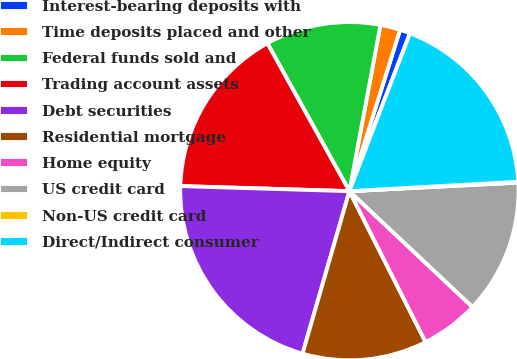Convert chart to OTSL. <chart><loc_0><loc_0><loc_500><loc_500><pie_chart><fcel>Interest-bearing deposits with<fcel>Time deposits placed and other<fcel>Federal funds sold and<fcel>Trading account assets<fcel>Debt securities<fcel>Residential mortgage<fcel>Home equity<fcel>US credit card<fcel>Non-US credit card<fcel>Direct/Indirect consumer<nl><fcel>0.99%<fcel>1.9%<fcel>11.0%<fcel>16.46%<fcel>21.01%<fcel>11.91%<fcel>5.54%<fcel>12.82%<fcel>0.08%<fcel>18.28%<nl></chart> 